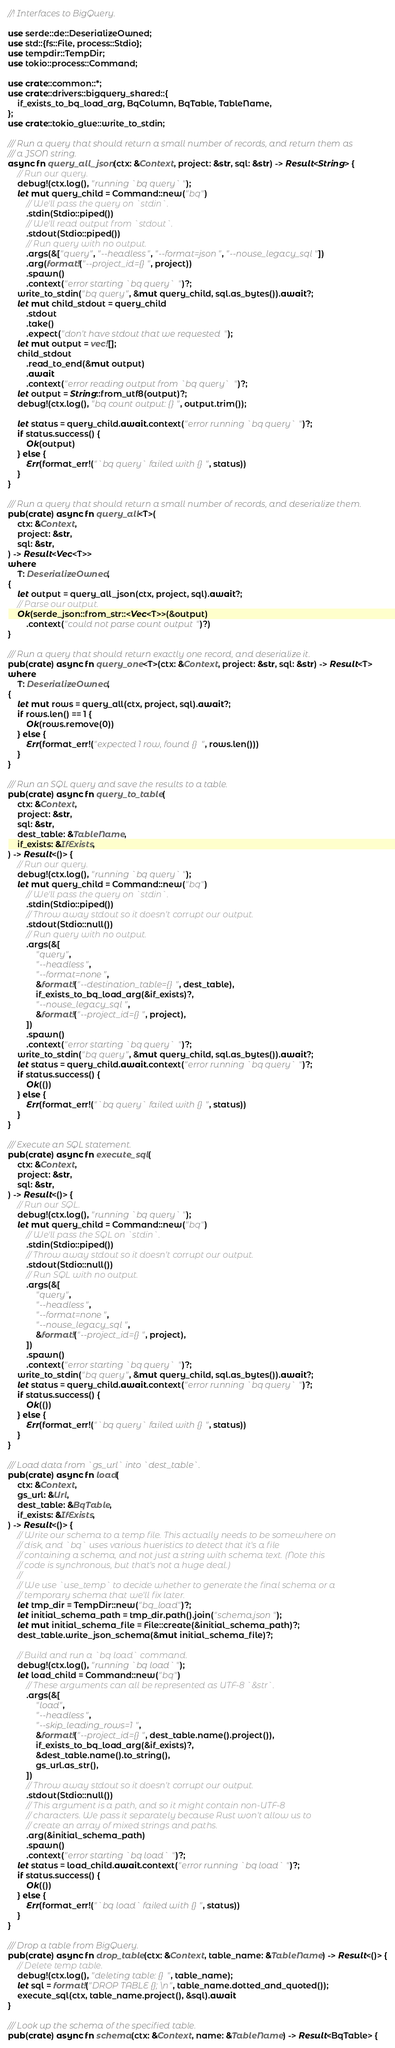Convert code to text. <code><loc_0><loc_0><loc_500><loc_500><_Rust_>//! Interfaces to BigQuery.

use serde::de::DeserializeOwned;
use std::{fs::File, process::Stdio};
use tempdir::TempDir;
use tokio::process::Command;

use crate::common::*;
use crate::drivers::bigquery_shared::{
    if_exists_to_bq_load_arg, BqColumn, BqTable, TableName,
};
use crate::tokio_glue::write_to_stdin;

/// Run a query that should return a small number of records, and return them as
/// a JSON string.
async fn query_all_json(ctx: &Context, project: &str, sql: &str) -> Result<String> {
    // Run our query.
    debug!(ctx.log(), "running `bq query`");
    let mut query_child = Command::new("bq")
        // We'll pass the query on `stdin`.
        .stdin(Stdio::piped())
        // We'll read output from `stdout`.
        .stdout(Stdio::piped())
        // Run query with no output.
        .args(&["query", "--headless", "--format=json", "--nouse_legacy_sql"])
        .arg(format!("--project_id={}", project))
        .spawn()
        .context("error starting `bq query`")?;
    write_to_stdin("bq query", &mut query_child, sql.as_bytes()).await?;
    let mut child_stdout = query_child
        .stdout
        .take()
        .expect("don't have stdout that we requested");
    let mut output = vec![];
    child_stdout
        .read_to_end(&mut output)
        .await
        .context("error reading output from `bq query`")?;
    let output = String::from_utf8(output)?;
    debug!(ctx.log(), "bq count output: {}", output.trim());

    let status = query_child.await.context("error running `bq query`")?;
    if status.success() {
        Ok(output)
    } else {
        Err(format_err!("`bq query` failed with {}", status))
    }
}

/// Run a query that should return a small number of records, and deserialize them.
pub(crate) async fn query_all<T>(
    ctx: &Context,
    project: &str,
    sql: &str,
) -> Result<Vec<T>>
where
    T: DeserializeOwned,
{
    let output = query_all_json(ctx, project, sql).await?;
    // Parse our output.
    Ok(serde_json::from_str::<Vec<T>>(&output)
        .context("could not parse count output")?)
}

/// Run a query that should return exactly one record, and deserialize it.
pub(crate) async fn query_one<T>(ctx: &Context, project: &str, sql: &str) -> Result<T>
where
    T: DeserializeOwned,
{
    let mut rows = query_all(ctx, project, sql).await?;
    if rows.len() == 1 {
        Ok(rows.remove(0))
    } else {
        Err(format_err!("expected 1 row, found {}", rows.len()))
    }
}

/// Run an SQL query and save the results to a table.
pub(crate) async fn query_to_table(
    ctx: &Context,
    project: &str,
    sql: &str,
    dest_table: &TableName,
    if_exists: &IfExists,
) -> Result<()> {
    // Run our query.
    debug!(ctx.log(), "running `bq query`");
    let mut query_child = Command::new("bq")
        // We'll pass the query on `stdin`.
        .stdin(Stdio::piped())
        // Throw away stdout so it doesn't corrupt our output.
        .stdout(Stdio::null())
        // Run query with no output.
        .args(&[
            "query",
            "--headless",
            "--format=none",
            &format!("--destination_table={}", dest_table),
            if_exists_to_bq_load_arg(&if_exists)?,
            "--nouse_legacy_sql",
            &format!("--project_id={}", project),
        ])
        .spawn()
        .context("error starting `bq query`")?;
    write_to_stdin("bq query", &mut query_child, sql.as_bytes()).await?;
    let status = query_child.await.context("error running `bq query`")?;
    if status.success() {
        Ok(())
    } else {
        Err(format_err!("`bq query` failed with {}", status))
    }
}

/// Execute an SQL statement.
pub(crate) async fn execute_sql(
    ctx: &Context,
    project: &str,
    sql: &str,
) -> Result<()> {
    // Run our SQL.
    debug!(ctx.log(), "running `bq query`");
    let mut query_child = Command::new("bq")
        // We'll pass the SQL on `stdin`.
        .stdin(Stdio::piped())
        // Throw away stdout so it doesn't corrupt our output.
        .stdout(Stdio::null())
        // Run SQL with no output.
        .args(&[
            "query",
            "--headless",
            "--format=none",
            "--nouse_legacy_sql",
            &format!("--project_id={}", project),
        ])
        .spawn()
        .context("error starting `bq query`")?;
    write_to_stdin("bq query", &mut query_child, sql.as_bytes()).await?;
    let status = query_child.await.context("error running `bq query`")?;
    if status.success() {
        Ok(())
    } else {
        Err(format_err!("`bq query` failed with {}", status))
    }
}

/// Load data from `gs_url` into `dest_table`.
pub(crate) async fn load(
    ctx: &Context,
    gs_url: &Url,
    dest_table: &BqTable,
    if_exists: &IfExists,
) -> Result<()> {
    // Write our schema to a temp file. This actually needs to be somewhere on
    // disk, and `bq` uses various hueristics to detect that it's a file
    // containing a schema, and not just a string with schema text. (Note this
    // code is synchronous, but that's not a huge deal.)
    //
    // We use `use_temp` to decide whether to generate the final schema or a
    // temporary schema that we'll fix later.
    let tmp_dir = TempDir::new("bq_load")?;
    let initial_schema_path = tmp_dir.path().join("schema.json");
    let mut initial_schema_file = File::create(&initial_schema_path)?;
    dest_table.write_json_schema(&mut initial_schema_file)?;

    // Build and run a `bq load` command.
    debug!(ctx.log(), "running `bq load`");
    let load_child = Command::new("bq")
        // These arguments can all be represented as UTF-8 `&str`.
        .args(&[
            "load",
            "--headless",
            "--skip_leading_rows=1",
            &format!("--project_id={}", dest_table.name().project()),
            if_exists_to_bq_load_arg(&if_exists)?,
            &dest_table.name().to_string(),
            gs_url.as_str(),
        ])
        // Throw away stdout so it doesn't corrupt our output.
        .stdout(Stdio::null())
        // This argument is a path, and so it might contain non-UTF-8
        // characters. We pass it separately because Rust won't allow us to
        // create an array of mixed strings and paths.
        .arg(&initial_schema_path)
        .spawn()
        .context("error starting `bq load`")?;
    let status = load_child.await.context("error running `bq load`")?;
    if status.success() {
        Ok(())
    } else {
        Err(format_err!("`bq load` failed with {}", status))
    }
}

/// Drop a table from BigQuery.
pub(crate) async fn drop_table(ctx: &Context, table_name: &TableName) -> Result<()> {
    // Delete temp table.
    debug!(ctx.log(), "deleting table: {}", table_name);
    let sql = format!("DROP TABLE {};\n", table_name.dotted_and_quoted());
    execute_sql(ctx, table_name.project(), &sql).await
}

/// Look up the schema of the specified table.
pub(crate) async fn schema(ctx: &Context, name: &TableName) -> Result<BqTable> {</code> 